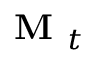<formula> <loc_0><loc_0><loc_500><loc_500>M _ { t }</formula> 